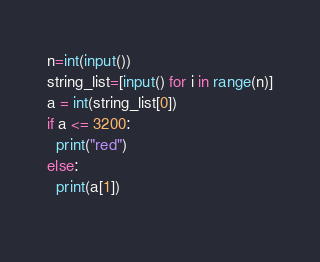Convert code to text. <code><loc_0><loc_0><loc_500><loc_500><_Python_>n=int(input())
string_list=[input() for i in range(n)]
a = int(string_list[0])
if a <= 3200:
  print("red")
else:
  print(a[1])
  </code> 